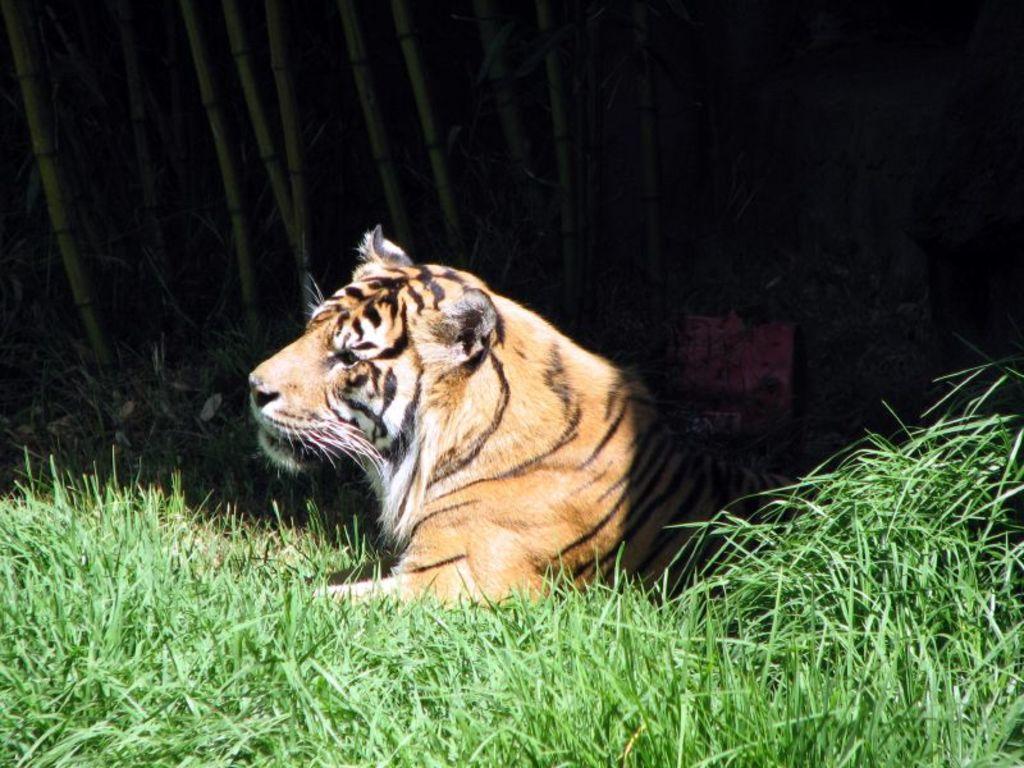How would you summarize this image in a sentence or two? This is the picture of a tiger which is on the grass floor. 